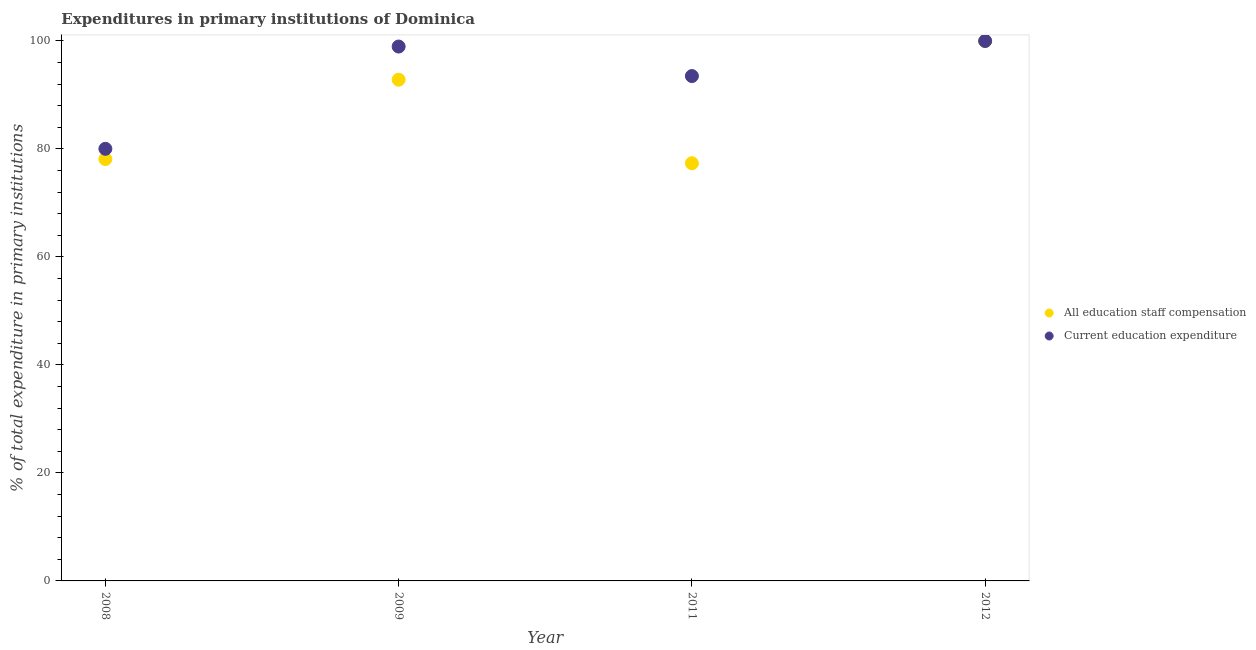What is the expenditure in staff compensation in 2012?
Make the answer very short. 100. Across all years, what is the minimum expenditure in staff compensation?
Make the answer very short. 77.36. In which year was the expenditure in staff compensation maximum?
Make the answer very short. 2012. In which year was the expenditure in staff compensation minimum?
Give a very brief answer. 2011. What is the total expenditure in education in the graph?
Keep it short and to the point. 372.5. What is the difference between the expenditure in staff compensation in 2009 and that in 2012?
Provide a short and direct response. -7.17. What is the difference between the expenditure in education in 2011 and the expenditure in staff compensation in 2009?
Make the answer very short. 0.68. What is the average expenditure in staff compensation per year?
Your answer should be compact. 87.08. In the year 2008, what is the difference between the expenditure in education and expenditure in staff compensation?
Offer a terse response. 1.9. In how many years, is the expenditure in staff compensation greater than 32 %?
Offer a terse response. 4. What is the ratio of the expenditure in education in 2011 to that in 2012?
Make the answer very short. 0.94. Is the expenditure in staff compensation in 2008 less than that in 2009?
Provide a short and direct response. Yes. What is the difference between the highest and the second highest expenditure in education?
Your answer should be very brief. 1.03. What is the difference between the highest and the lowest expenditure in education?
Your answer should be compact. 19.97. Does the expenditure in staff compensation monotonically increase over the years?
Offer a terse response. No. Is the expenditure in education strictly greater than the expenditure in staff compensation over the years?
Your answer should be very brief. No. How many years are there in the graph?
Provide a succinct answer. 4. What is the difference between two consecutive major ticks on the Y-axis?
Your answer should be compact. 20. How are the legend labels stacked?
Offer a terse response. Vertical. What is the title of the graph?
Offer a very short reply. Expenditures in primary institutions of Dominica. Does "Drinking water services" appear as one of the legend labels in the graph?
Provide a short and direct response. No. What is the label or title of the Y-axis?
Offer a very short reply. % of total expenditure in primary institutions. What is the % of total expenditure in primary institutions of All education staff compensation in 2008?
Your response must be concise. 78.13. What is the % of total expenditure in primary institutions in Current education expenditure in 2008?
Provide a succinct answer. 80.03. What is the % of total expenditure in primary institutions of All education staff compensation in 2009?
Your answer should be compact. 92.83. What is the % of total expenditure in primary institutions of Current education expenditure in 2009?
Your answer should be very brief. 98.97. What is the % of total expenditure in primary institutions of All education staff compensation in 2011?
Ensure brevity in your answer.  77.36. What is the % of total expenditure in primary institutions in Current education expenditure in 2011?
Your answer should be very brief. 93.5. What is the % of total expenditure in primary institutions of All education staff compensation in 2012?
Ensure brevity in your answer.  100. Across all years, what is the maximum % of total expenditure in primary institutions in Current education expenditure?
Ensure brevity in your answer.  100. Across all years, what is the minimum % of total expenditure in primary institutions of All education staff compensation?
Make the answer very short. 77.36. Across all years, what is the minimum % of total expenditure in primary institutions in Current education expenditure?
Provide a succinct answer. 80.03. What is the total % of total expenditure in primary institutions in All education staff compensation in the graph?
Give a very brief answer. 348.32. What is the total % of total expenditure in primary institutions of Current education expenditure in the graph?
Your answer should be compact. 372.5. What is the difference between the % of total expenditure in primary institutions in All education staff compensation in 2008 and that in 2009?
Offer a very short reply. -14.7. What is the difference between the % of total expenditure in primary institutions in Current education expenditure in 2008 and that in 2009?
Your answer should be very brief. -18.94. What is the difference between the % of total expenditure in primary institutions in All education staff compensation in 2008 and that in 2011?
Give a very brief answer. 0.77. What is the difference between the % of total expenditure in primary institutions in Current education expenditure in 2008 and that in 2011?
Make the answer very short. -13.48. What is the difference between the % of total expenditure in primary institutions of All education staff compensation in 2008 and that in 2012?
Offer a terse response. -21.87. What is the difference between the % of total expenditure in primary institutions in Current education expenditure in 2008 and that in 2012?
Provide a short and direct response. -19.97. What is the difference between the % of total expenditure in primary institutions in All education staff compensation in 2009 and that in 2011?
Offer a very short reply. 15.47. What is the difference between the % of total expenditure in primary institutions in Current education expenditure in 2009 and that in 2011?
Offer a very short reply. 5.47. What is the difference between the % of total expenditure in primary institutions of All education staff compensation in 2009 and that in 2012?
Make the answer very short. -7.17. What is the difference between the % of total expenditure in primary institutions of Current education expenditure in 2009 and that in 2012?
Keep it short and to the point. -1.03. What is the difference between the % of total expenditure in primary institutions in All education staff compensation in 2011 and that in 2012?
Provide a short and direct response. -22.64. What is the difference between the % of total expenditure in primary institutions in Current education expenditure in 2011 and that in 2012?
Provide a succinct answer. -6.5. What is the difference between the % of total expenditure in primary institutions in All education staff compensation in 2008 and the % of total expenditure in primary institutions in Current education expenditure in 2009?
Offer a very short reply. -20.84. What is the difference between the % of total expenditure in primary institutions of All education staff compensation in 2008 and the % of total expenditure in primary institutions of Current education expenditure in 2011?
Keep it short and to the point. -15.38. What is the difference between the % of total expenditure in primary institutions of All education staff compensation in 2008 and the % of total expenditure in primary institutions of Current education expenditure in 2012?
Give a very brief answer. -21.87. What is the difference between the % of total expenditure in primary institutions of All education staff compensation in 2009 and the % of total expenditure in primary institutions of Current education expenditure in 2011?
Keep it short and to the point. -0.68. What is the difference between the % of total expenditure in primary institutions in All education staff compensation in 2009 and the % of total expenditure in primary institutions in Current education expenditure in 2012?
Your response must be concise. -7.17. What is the difference between the % of total expenditure in primary institutions in All education staff compensation in 2011 and the % of total expenditure in primary institutions in Current education expenditure in 2012?
Offer a terse response. -22.64. What is the average % of total expenditure in primary institutions in All education staff compensation per year?
Offer a terse response. 87.08. What is the average % of total expenditure in primary institutions in Current education expenditure per year?
Your answer should be compact. 93.13. In the year 2008, what is the difference between the % of total expenditure in primary institutions in All education staff compensation and % of total expenditure in primary institutions in Current education expenditure?
Keep it short and to the point. -1.9. In the year 2009, what is the difference between the % of total expenditure in primary institutions in All education staff compensation and % of total expenditure in primary institutions in Current education expenditure?
Provide a succinct answer. -6.14. In the year 2011, what is the difference between the % of total expenditure in primary institutions in All education staff compensation and % of total expenditure in primary institutions in Current education expenditure?
Offer a terse response. -16.14. In the year 2012, what is the difference between the % of total expenditure in primary institutions of All education staff compensation and % of total expenditure in primary institutions of Current education expenditure?
Make the answer very short. 0. What is the ratio of the % of total expenditure in primary institutions of All education staff compensation in 2008 to that in 2009?
Your answer should be very brief. 0.84. What is the ratio of the % of total expenditure in primary institutions in Current education expenditure in 2008 to that in 2009?
Keep it short and to the point. 0.81. What is the ratio of the % of total expenditure in primary institutions in All education staff compensation in 2008 to that in 2011?
Give a very brief answer. 1.01. What is the ratio of the % of total expenditure in primary institutions in Current education expenditure in 2008 to that in 2011?
Offer a terse response. 0.86. What is the ratio of the % of total expenditure in primary institutions of All education staff compensation in 2008 to that in 2012?
Ensure brevity in your answer.  0.78. What is the ratio of the % of total expenditure in primary institutions in Current education expenditure in 2008 to that in 2012?
Your answer should be compact. 0.8. What is the ratio of the % of total expenditure in primary institutions of All education staff compensation in 2009 to that in 2011?
Provide a short and direct response. 1.2. What is the ratio of the % of total expenditure in primary institutions of Current education expenditure in 2009 to that in 2011?
Your response must be concise. 1.06. What is the ratio of the % of total expenditure in primary institutions in All education staff compensation in 2009 to that in 2012?
Ensure brevity in your answer.  0.93. What is the ratio of the % of total expenditure in primary institutions of Current education expenditure in 2009 to that in 2012?
Offer a terse response. 0.99. What is the ratio of the % of total expenditure in primary institutions of All education staff compensation in 2011 to that in 2012?
Provide a short and direct response. 0.77. What is the ratio of the % of total expenditure in primary institutions in Current education expenditure in 2011 to that in 2012?
Ensure brevity in your answer.  0.94. What is the difference between the highest and the second highest % of total expenditure in primary institutions of All education staff compensation?
Your answer should be compact. 7.17. What is the difference between the highest and the second highest % of total expenditure in primary institutions of Current education expenditure?
Provide a short and direct response. 1.03. What is the difference between the highest and the lowest % of total expenditure in primary institutions of All education staff compensation?
Keep it short and to the point. 22.64. What is the difference between the highest and the lowest % of total expenditure in primary institutions of Current education expenditure?
Your response must be concise. 19.97. 